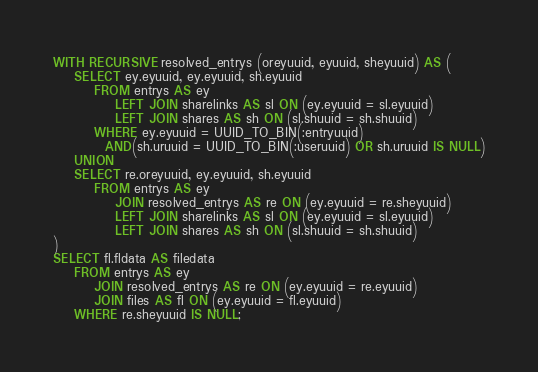<code> <loc_0><loc_0><loc_500><loc_500><_SQL_>WITH RECURSIVE resolved_entrys (oreyuuid, eyuuid, sheyuuid) AS (
    SELECT ey.eyuuid, ey.eyuuid, sh.eyuuid
        FROM entrys AS ey
            LEFT JOIN sharelinks AS sl ON (ey.eyuuid = sl.eyuuid)
            LEFT JOIN shares AS sh ON (sl.shuuid = sh.shuuid)
    	WHERE ey.eyuuid = UUID_TO_BIN(:entryuuid)
          AND(sh.uruuid = UUID_TO_BIN(:useruuid) OR sh.uruuid IS NULL)
    UNION
    SELECT re.oreyuuid, ey.eyuuid, sh.eyuuid
        FROM entrys AS ey
            JOIN resolved_entrys AS re ON (ey.eyuuid = re.sheyuuid)
            LEFT JOIN sharelinks AS sl ON (ey.eyuuid = sl.eyuuid)
            LEFT JOIN shares AS sh ON (sl.shuuid = sh.shuuid)
)
SELECT fl.fldata AS filedata
    FROM entrys AS ey
        JOIN resolved_entrys AS re ON (ey.eyuuid = re.eyuuid)
        JOIN files AS fl ON (ey.eyuuid = fl.eyuuid)
    WHERE re.sheyuuid IS NULL;</code> 